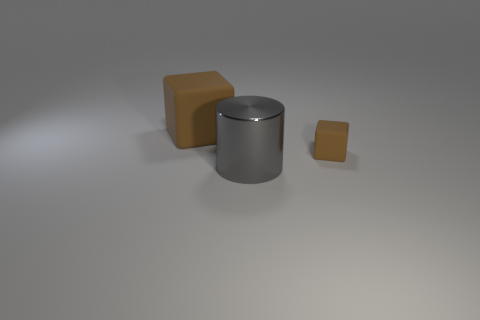Subtract 1 blocks. How many blocks are left? 1 Add 3 large purple cubes. How many objects exist? 6 Subtract all purple cylinders. Subtract all gray cubes. How many cylinders are left? 1 Subtract all cyan spheres. How many yellow cubes are left? 0 Subtract all large cubes. Subtract all gray things. How many objects are left? 1 Add 1 metal cylinders. How many metal cylinders are left? 2 Add 1 tiny objects. How many tiny objects exist? 2 Subtract 0 green cylinders. How many objects are left? 3 Subtract all cylinders. How many objects are left? 2 